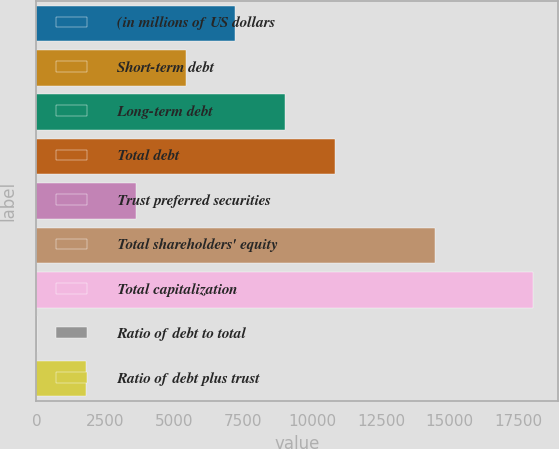<chart> <loc_0><loc_0><loc_500><loc_500><bar_chart><fcel>(in millions of US dollars<fcel>Short-term debt<fcel>Long-term debt<fcel>Total debt<fcel>Trust preferred securities<fcel>Total shareholders' equity<fcel>Total capitalization<fcel>Ratio of debt to total<fcel>Ratio of debt plus trust<nl><fcel>7223.72<fcel>5422.34<fcel>9025.1<fcel>10826.5<fcel>3620.96<fcel>14446<fcel>18032<fcel>18.2<fcel>1819.58<nl></chart> 